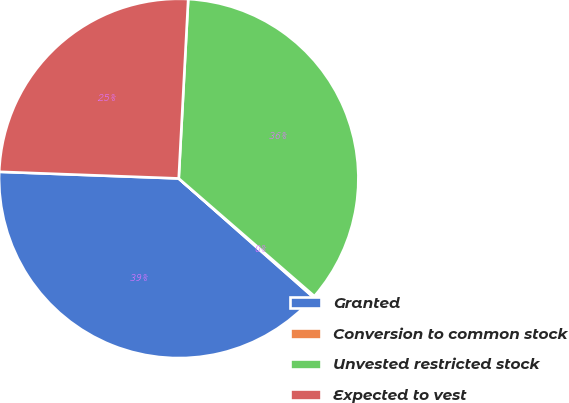<chart> <loc_0><loc_0><loc_500><loc_500><pie_chart><fcel>Granted<fcel>Conversion to common stock<fcel>Unvested restricted stock<fcel>Expected to vest<nl><fcel>39.08%<fcel>0.13%<fcel>35.53%<fcel>25.25%<nl></chart> 